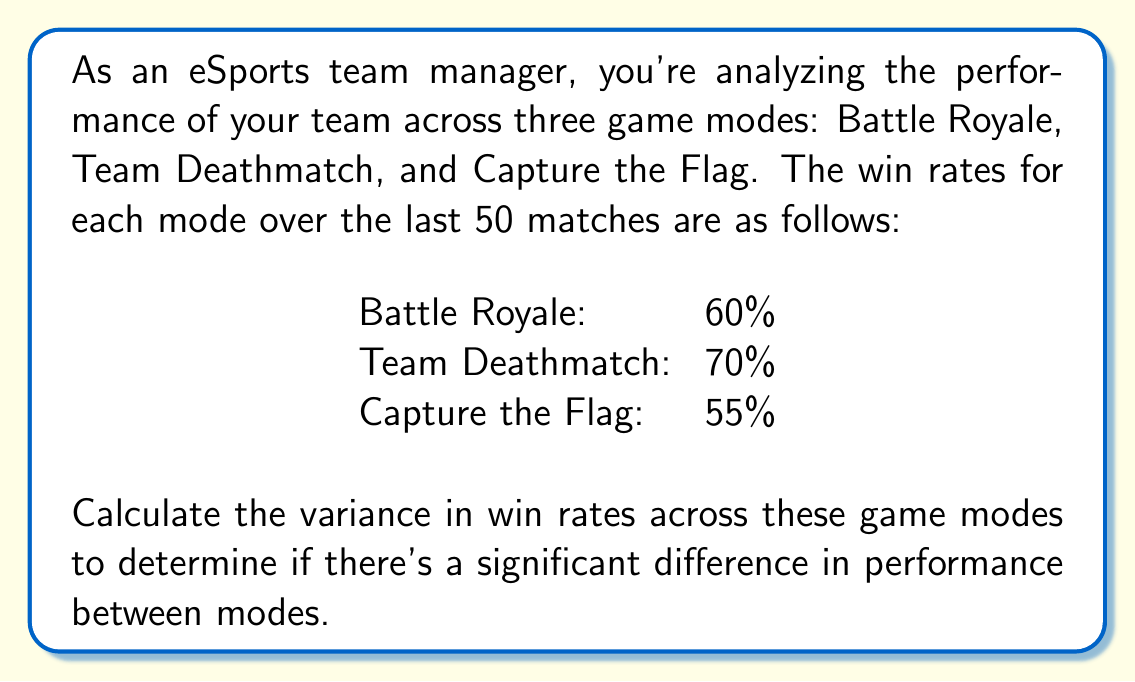Give your solution to this math problem. To calculate the variance in win rates, we'll follow these steps:

1. Calculate the mean win rate:
   $\mu = \frac{60\% + 70\% + 55\%}{3} = 61.67\%$

2. Calculate the squared differences from the mean:
   Battle Royale: $(60\% - 61.67\%)^2 = (-1.67\%)^2 = 0.0278\%$
   Team Deathmatch: $(70\% - 61.67\%)^2 = (8.33\%)^2 = 0.6944\%$
   Capture the Flag: $(55\% - 61.67\%)^2 = (-6.67\%)^2 = 0.4444\%$

3. Calculate the average of these squared differences:
   $\text{Variance} = \frac{0.0278\% + 0.6944\% + 0.4444\%}{3} = 0.3889\%$

4. Convert the percentage to a decimal:
   $\text{Variance} = 0.003889$

The variance in win rates across the three game modes is 0.003889 or 0.3889%.
Answer: 0.003889 